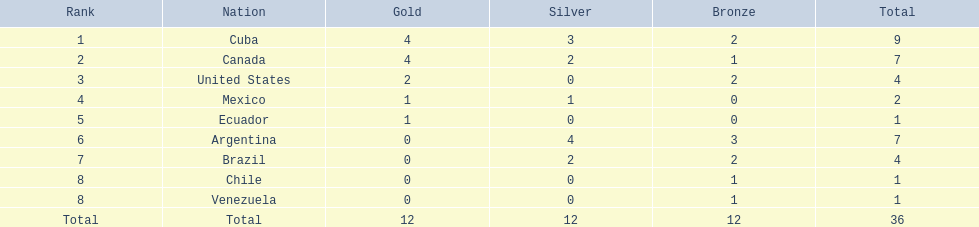Which countries took part? Cuba, Canada, United States, Mexico, Ecuador, Argentina, Brazil, Chile, Venezuela. Which countries secured gold? Cuba, Canada, United States, Mexico, Ecuador. Which countries failed to obtain silver? United States, Ecuador, Chile, Venezuela. Among the mentioned countries, which one achieved gold? United States. 